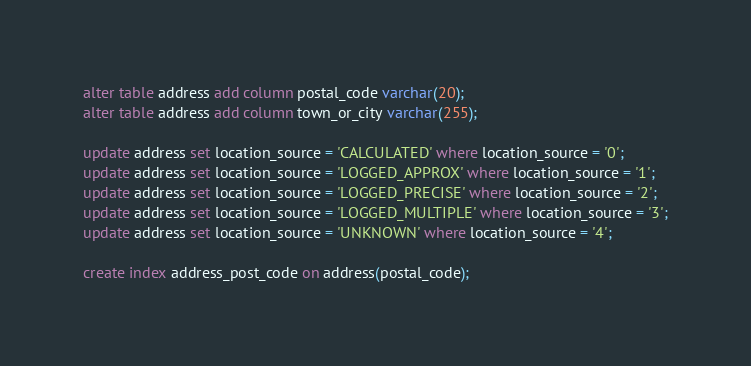<code> <loc_0><loc_0><loc_500><loc_500><_SQL_>alter table address add column postal_code varchar(20);
alter table address add column town_or_city varchar(255);

update address set location_source = 'CALCULATED' where location_source = '0';
update address set location_source = 'LOGGED_APPROX' where location_source = '1';
update address set location_source = 'LOGGED_PRECISE' where location_source = '2';
update address set location_source = 'LOGGED_MULTIPLE' where location_source = '3';
update address set location_source = 'UNKNOWN' where location_source = '4';

create index address_post_code on address(postal_code);</code> 